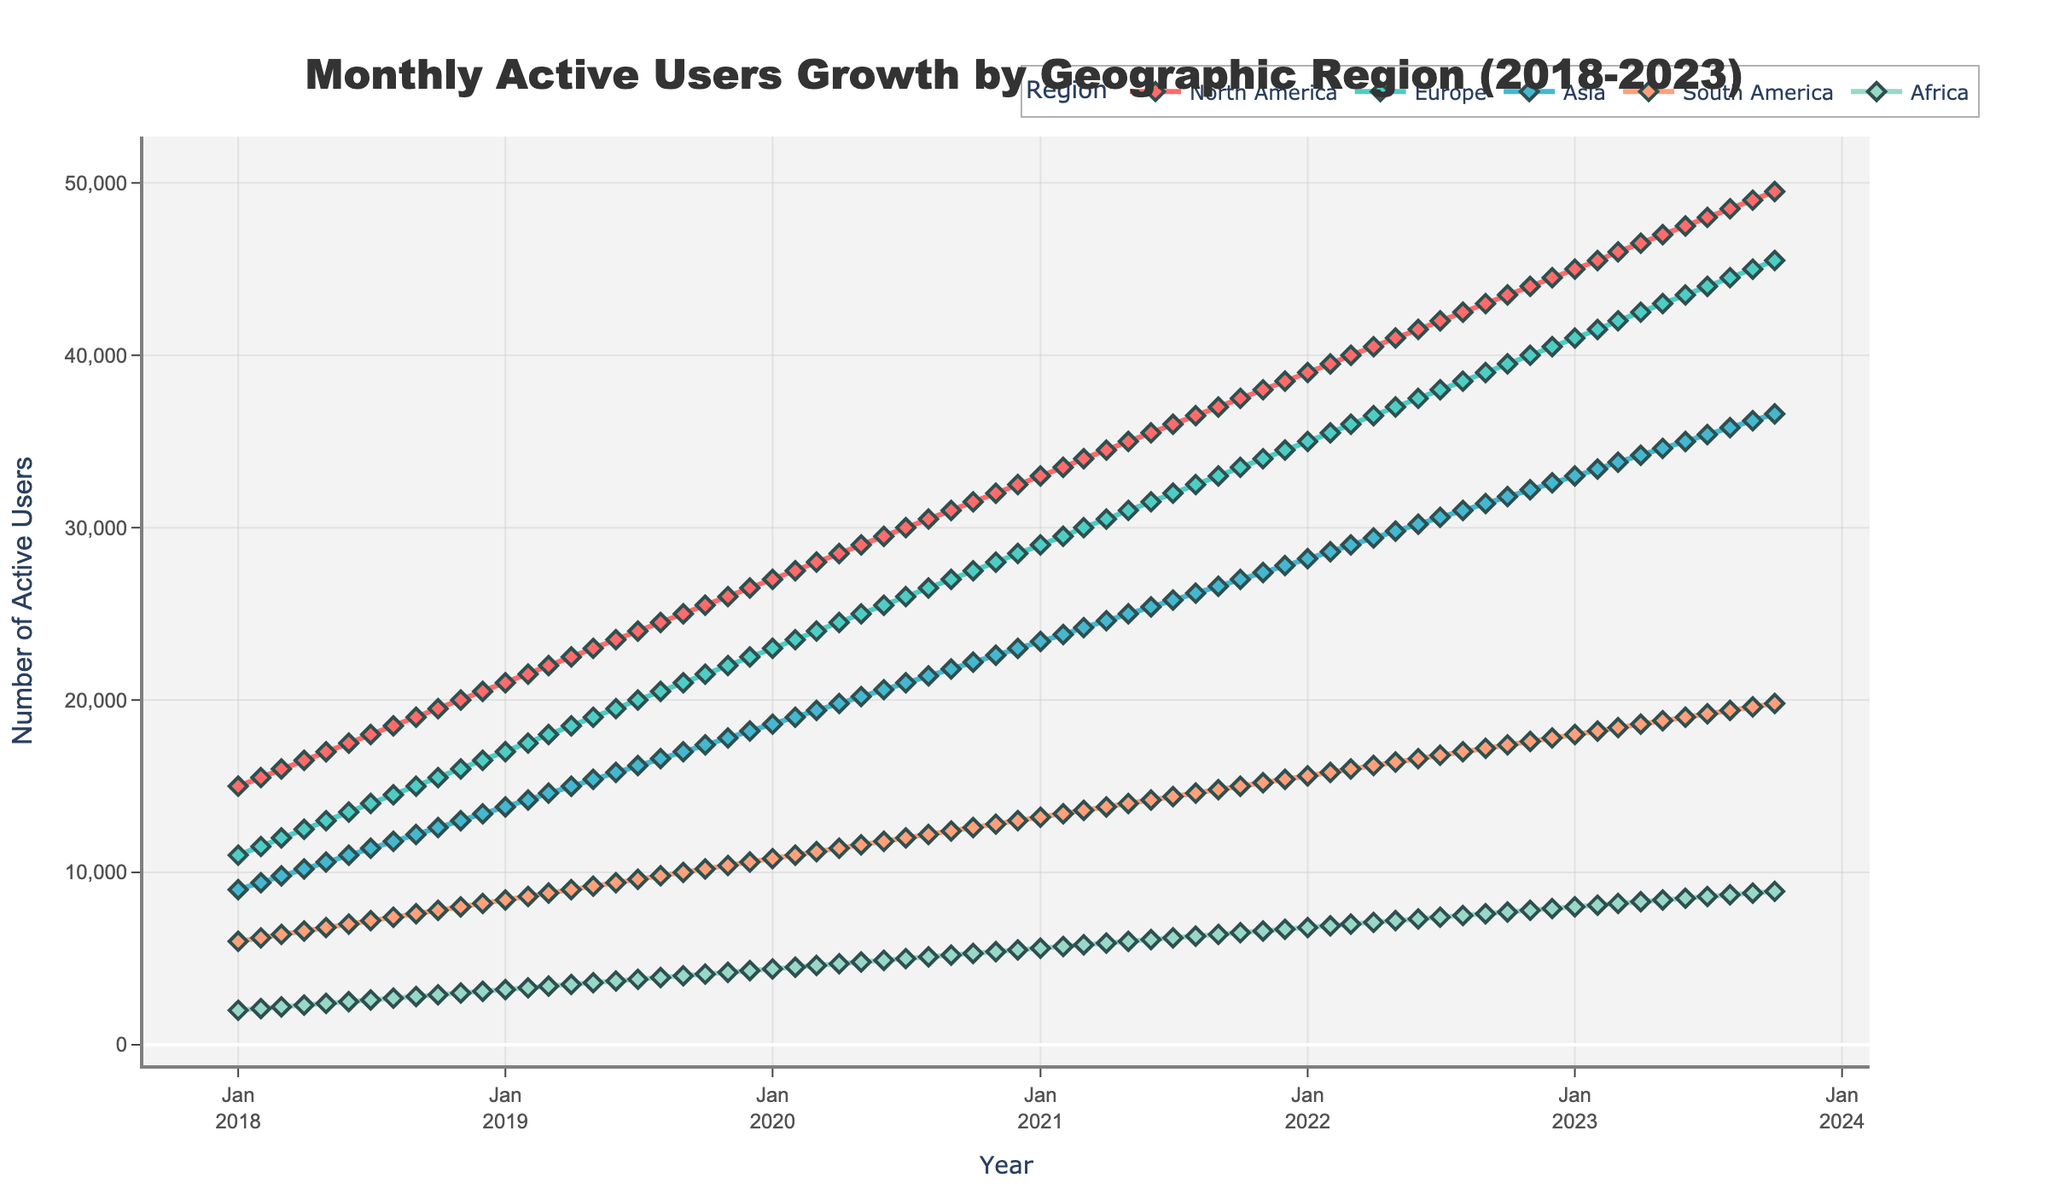What is the title of the plot? The title is the text displayed at the top of the plot. It provides a summary of what the plot represents.
Answer: Monthly Active Users Growth by Geographic Region (2018-2023) What are the colors used to represent each region? The plot uses different colors to distinguish each geographic region. By looking at the legend, you can identify the color for each region. North America is represented by red, Europe by teal, Asia by lighter blue, South America by light salmon, and Africa by light teal.
Answer: North America: red, Europe: teal, Asia: light blue, South America: light salmon, Africa: light teal How many data points are there for each region across the timeline? The timeline spans from January 2018 to October 2023. Each month represents a data point. By counting the months in this period, we get the number of data points. From January 2018 to October 2023 comprises 70 months.
Answer: 70 Which region had the highest number of users in October 2023? Look at the end of the timeline for October 2023 and compare the values of different regions. North America had the highest number of users with 49,500 users in October 2023.
Answer: North America What is the difference in active users between North America and Asia in January 2020? Check the values for North America and Asia for January 2020. North America has 27,000 users, and Asia has 18,600. The difference is calculated by subtracting the number of users in Asia from those in North America. 27,000 - 18,600 = 8,400.
Answer: 8,400 What is the average number of monthly active users in Europe over the five-year period? Sum the active users in Europe for each month from January 2018 to October 2023 and divide by the total number of months (70). The calculation involves adding all monthly values and dividing by 70. (11000 + 11500 + 12000 + ... + 45500) / 70 = 30000 (approx.)
Answer: ~30000 Which region showed the fastest growth rate in active users over the five-year period? To determine the fastest growth rate, compare the initial and final numbers for each region and calculate the difference. The region with the largest difference had the fastest growth rate. North America's user numbers grew from 15,000 in January 2018 to 49,500 in October 2023, which is a growth of 34,500, the highest among all regions.
Answer: North America How did the number of active users in Africa change from January 2019 to January 2020? Look at the user numbers for Africa in January 2019 and January 2020. In January 2019, there were 3,200 users, and in January 2020, there were 4,400 users. The change is calculated by subtracting the initial value from the final value. 4,400 - 3,200 = 1,200.
Answer: 1,200 Did any region experience a decline in active users at any point between 2018 and 2023? Examine the trend lines for each region from 2018 to 2023. If any region shows a downward slope at any point, it indicates a decline. No such decline is seen in the time series data for any region; all regions show a continuous increase.
Answer: No 